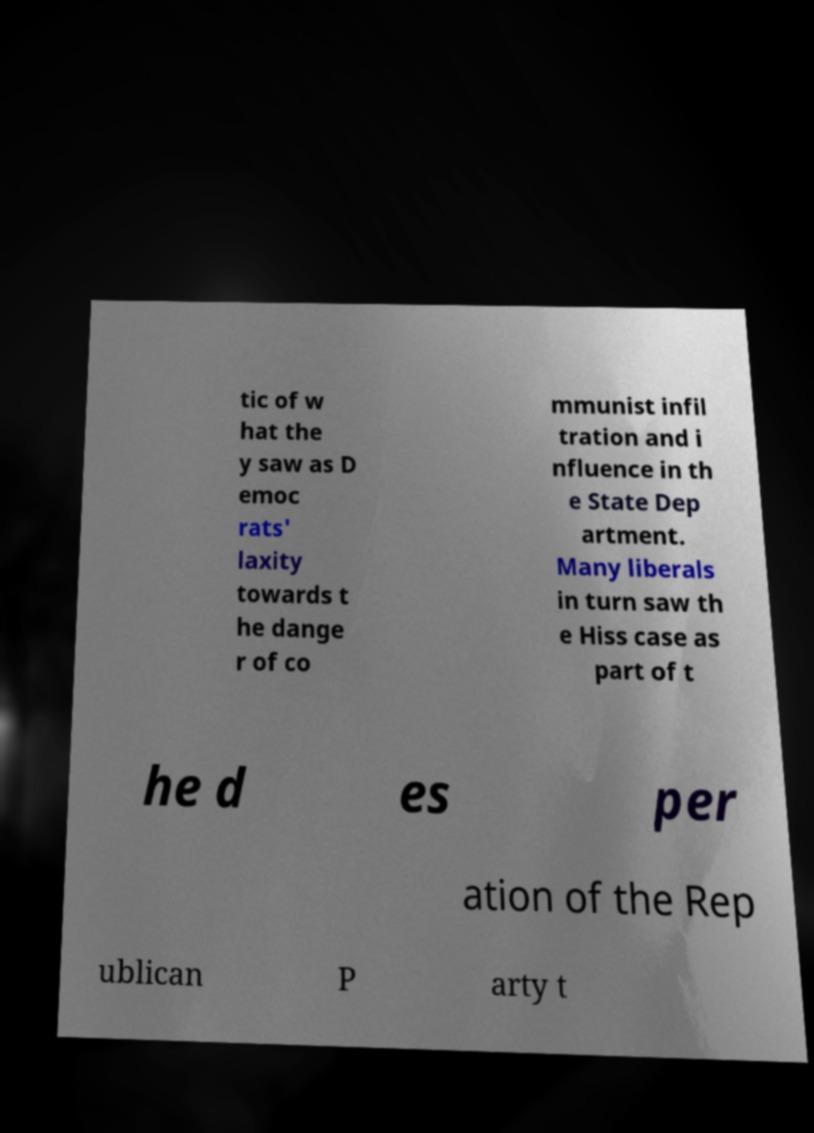Can you accurately transcribe the text from the provided image for me? tic of w hat the y saw as D emoc rats' laxity towards t he dange r of co mmunist infil tration and i nfluence in th e State Dep artment. Many liberals in turn saw th e Hiss case as part of t he d es per ation of the Rep ublican P arty t 